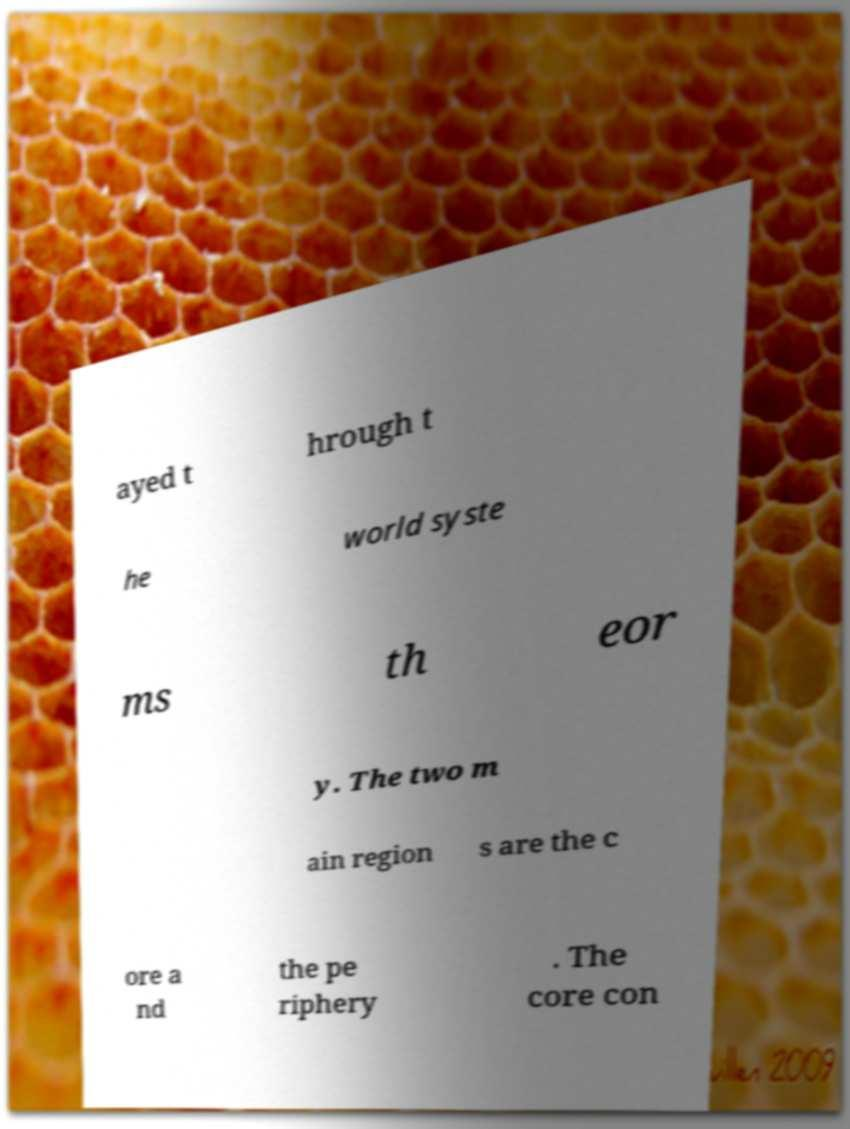For documentation purposes, I need the text within this image transcribed. Could you provide that? ayed t hrough t he world syste ms th eor y. The two m ain region s are the c ore a nd the pe riphery . The core con 